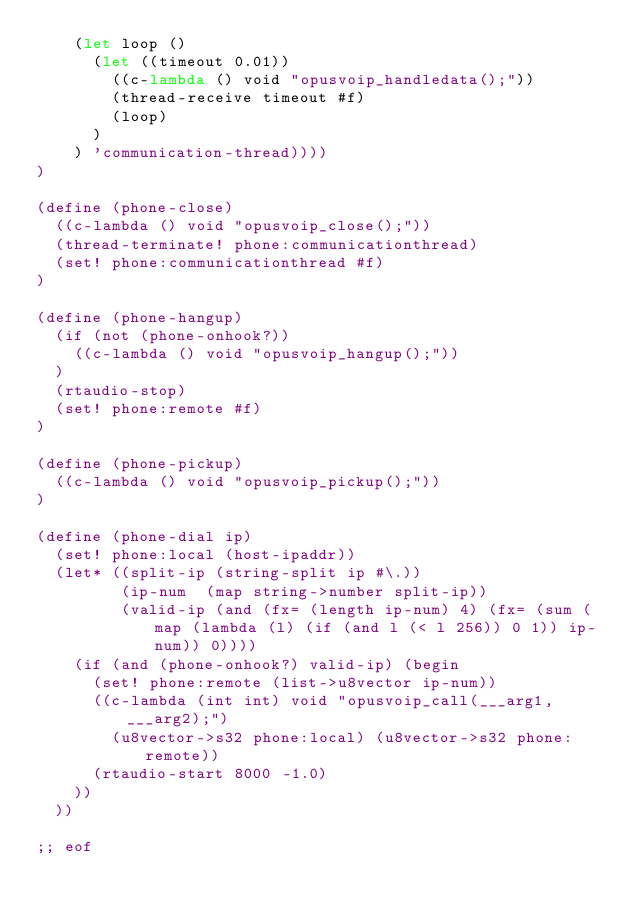<code> <loc_0><loc_0><loc_500><loc_500><_Scheme_>    (let loop ()
      (let ((timeout 0.01))
        ((c-lambda () void "opusvoip_handledata();"))
        (thread-receive timeout #f)
        (loop)
      )
    ) 'communication-thread))))
)

(define (phone-close)
  ((c-lambda () void "opusvoip_close();"))
  (thread-terminate! phone:communicationthread)
  (set! phone:communicationthread #f)
)

(define (phone-hangup)
  (if (not (phone-onhook?))
    ((c-lambda () void "opusvoip_hangup();"))
  )
  (rtaudio-stop)
  (set! phone:remote #f)
)

(define (phone-pickup)
  ((c-lambda () void "opusvoip_pickup();"))
)

(define (phone-dial ip)
  (set! phone:local (host-ipaddr))
  (let* ((split-ip (string-split ip #\.))
         (ip-num  (map string->number split-ip))
         (valid-ip (and (fx= (length ip-num) 4) (fx= (sum (map (lambda (l) (if (and l (< l 256)) 0 1)) ip-num)) 0))))
    (if (and (phone-onhook?) valid-ip) (begin
      (set! phone:remote (list->u8vector ip-num))
      ((c-lambda (int int) void "opusvoip_call(___arg1,___arg2);")
        (u8vector->s32 phone:local) (u8vector->s32 phone:remote))
      (rtaudio-start 8000 -1.0)
    ))
  ))

;; eof
</code> 